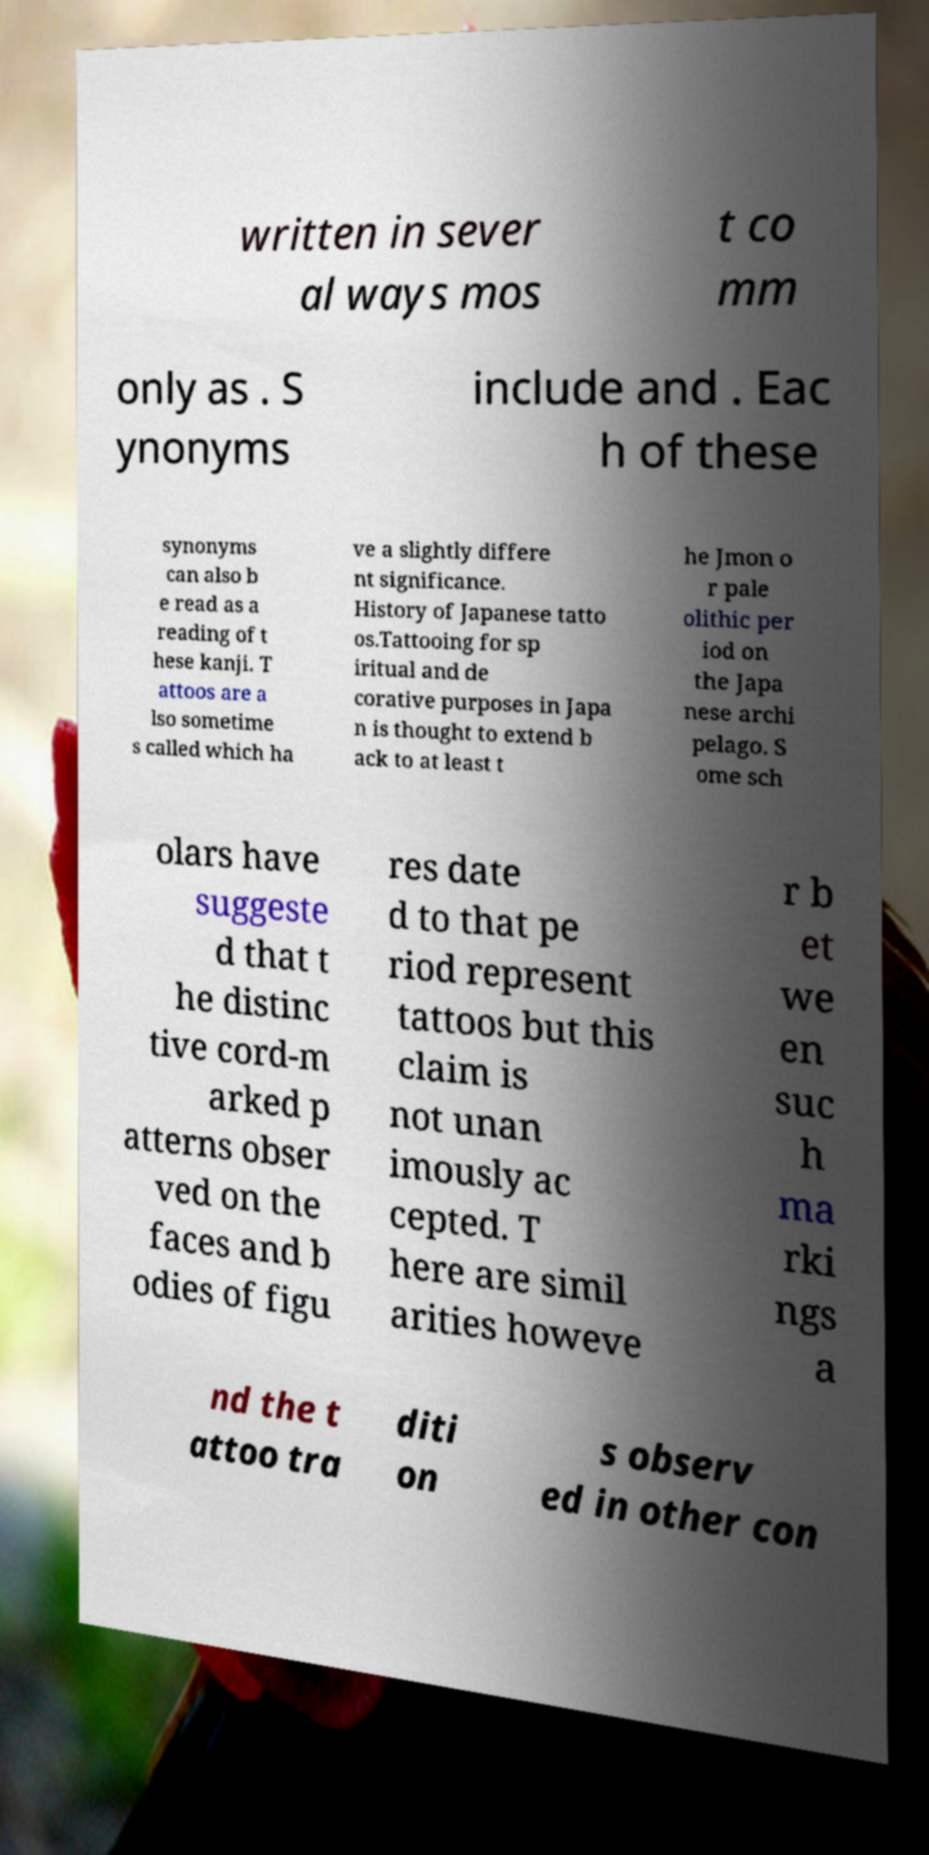Please identify and transcribe the text found in this image. written in sever al ways mos t co mm only as . S ynonyms include and . Eac h of these synonyms can also b e read as a reading of t hese kanji. T attoos are a lso sometime s called which ha ve a slightly differe nt significance. History of Japanese tatto os.Tattooing for sp iritual and de corative purposes in Japa n is thought to extend b ack to at least t he Jmon o r pale olithic per iod on the Japa nese archi pelago. S ome sch olars have suggeste d that t he distinc tive cord-m arked p atterns obser ved on the faces and b odies of figu res date d to that pe riod represent tattoos but this claim is not unan imously ac cepted. T here are simil arities howeve r b et we en suc h ma rki ngs a nd the t attoo tra diti on s observ ed in other con 